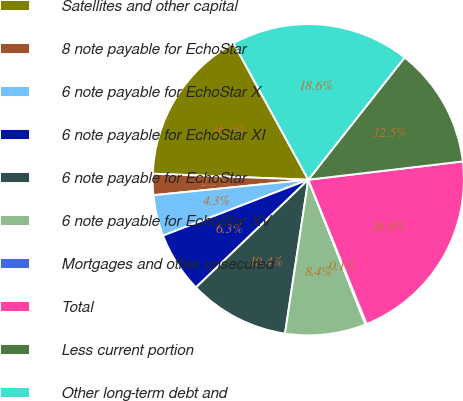<chart> <loc_0><loc_0><loc_500><loc_500><pie_chart><fcel>Satellites and other capital<fcel>8 note payable for EchoStar<fcel>6 note payable for EchoStar X<fcel>6 note payable for EchoStar XI<fcel>6 note payable for EchoStar<fcel>6 note payable for EchoStar XV<fcel>Mortgages and other unsecured<fcel>Total<fcel>Less current portion<fcel>Other long-term debt and<nl><fcel>16.41%<fcel>2.2%<fcel>4.26%<fcel>6.32%<fcel>10.44%<fcel>8.38%<fcel>0.13%<fcel>20.75%<fcel>12.5%<fcel>18.6%<nl></chart> 